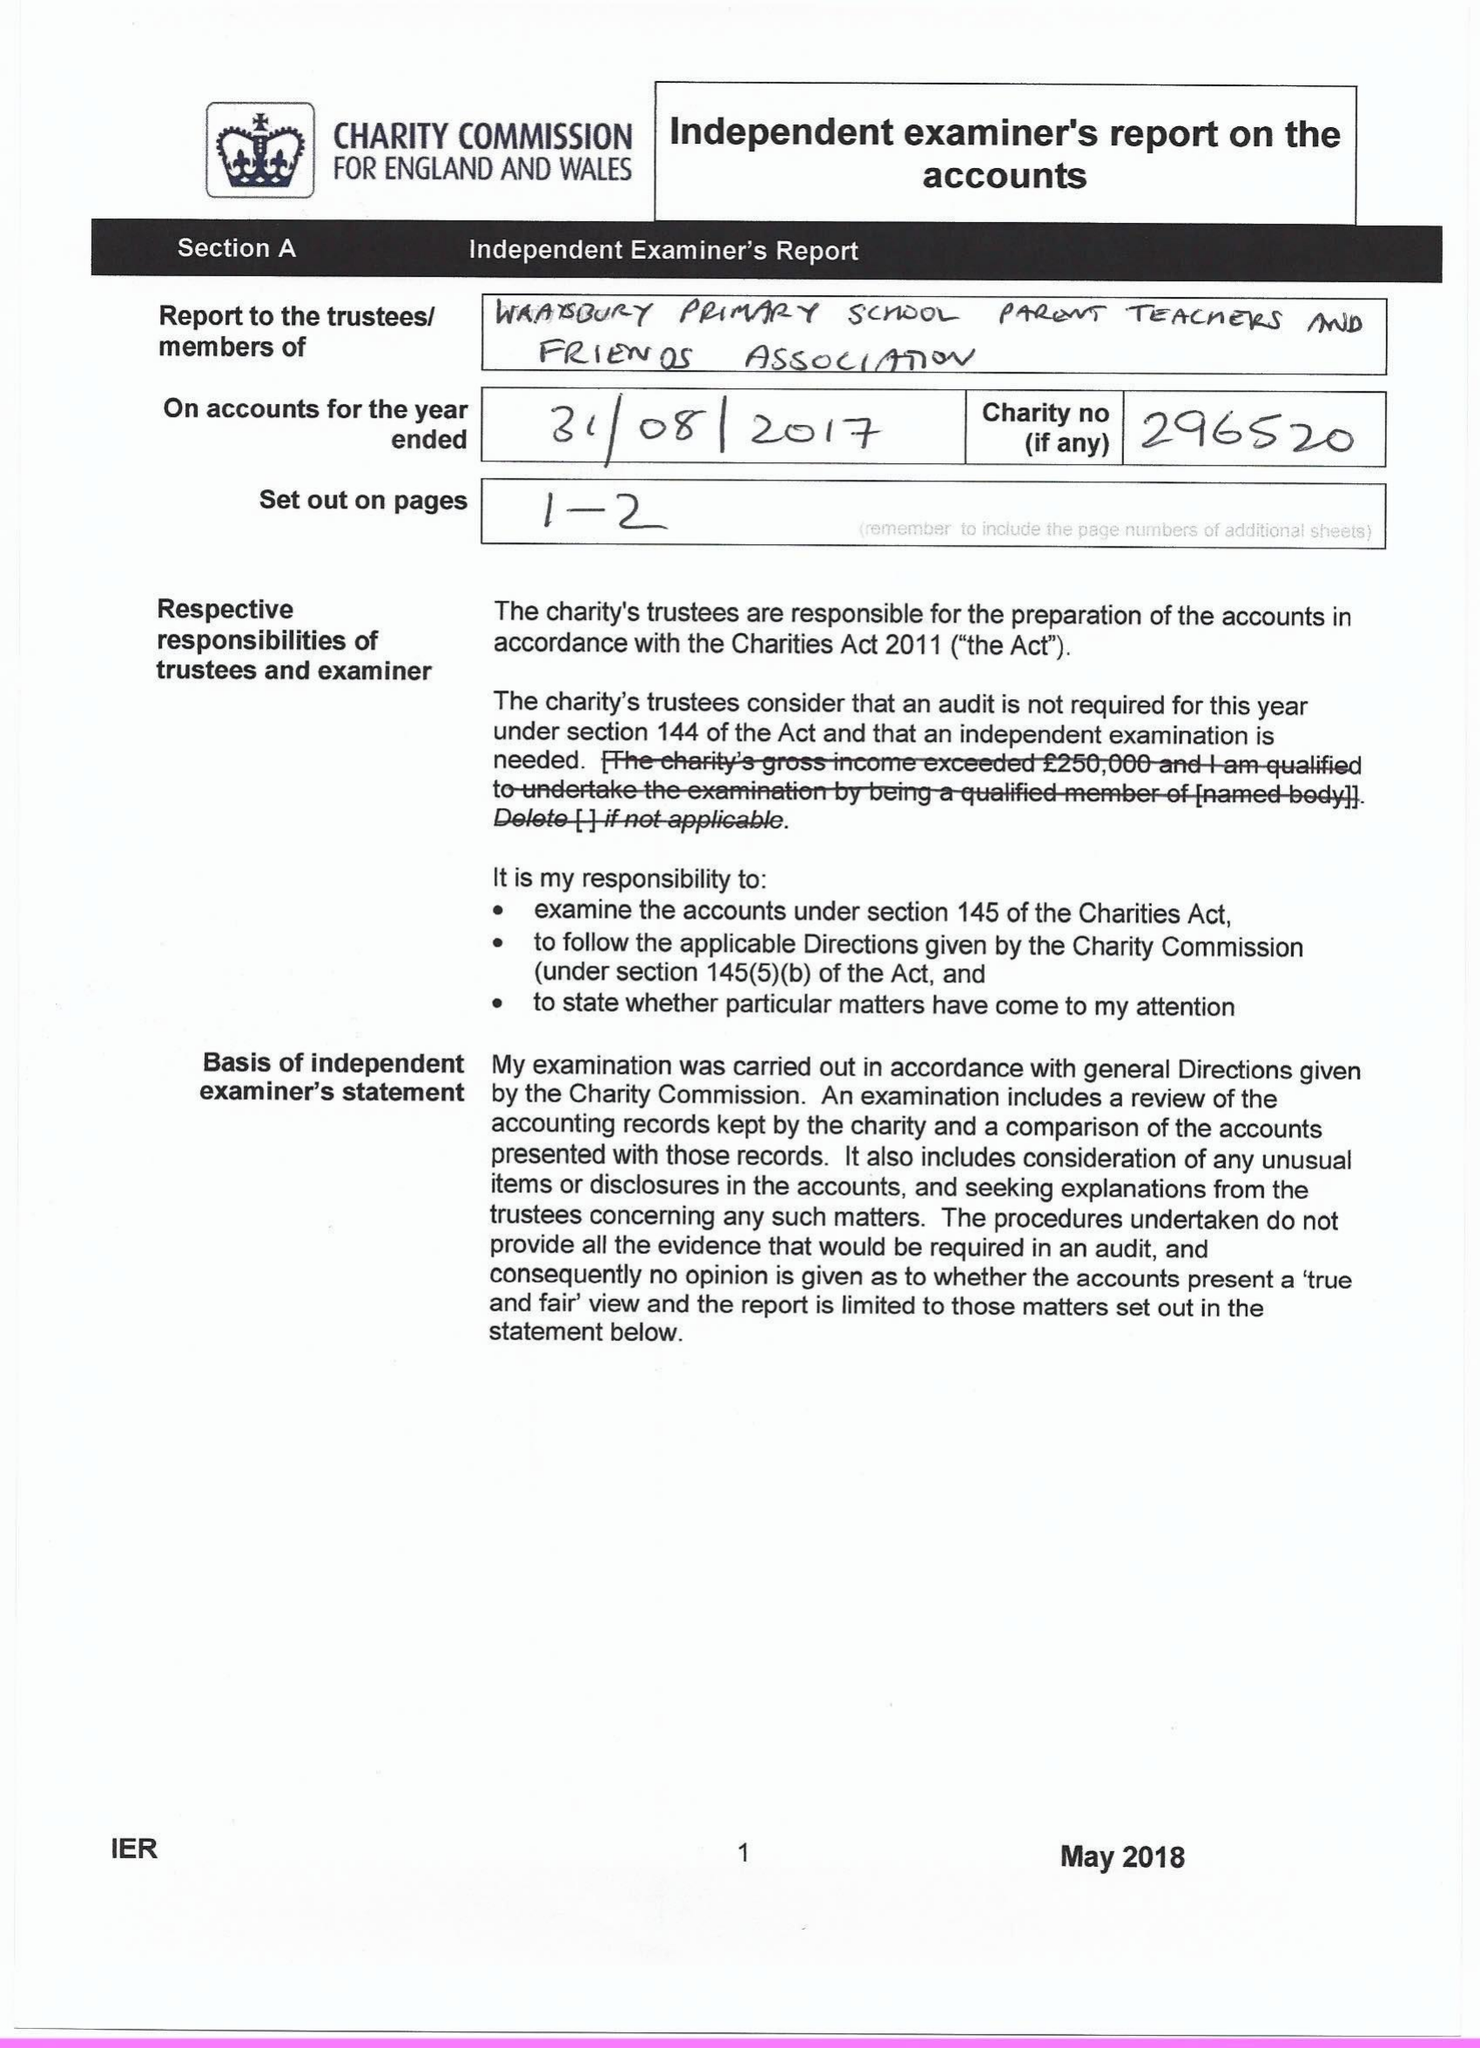What is the value for the address__postcode?
Answer the question using a single word or phrase. TW19 5DJ 